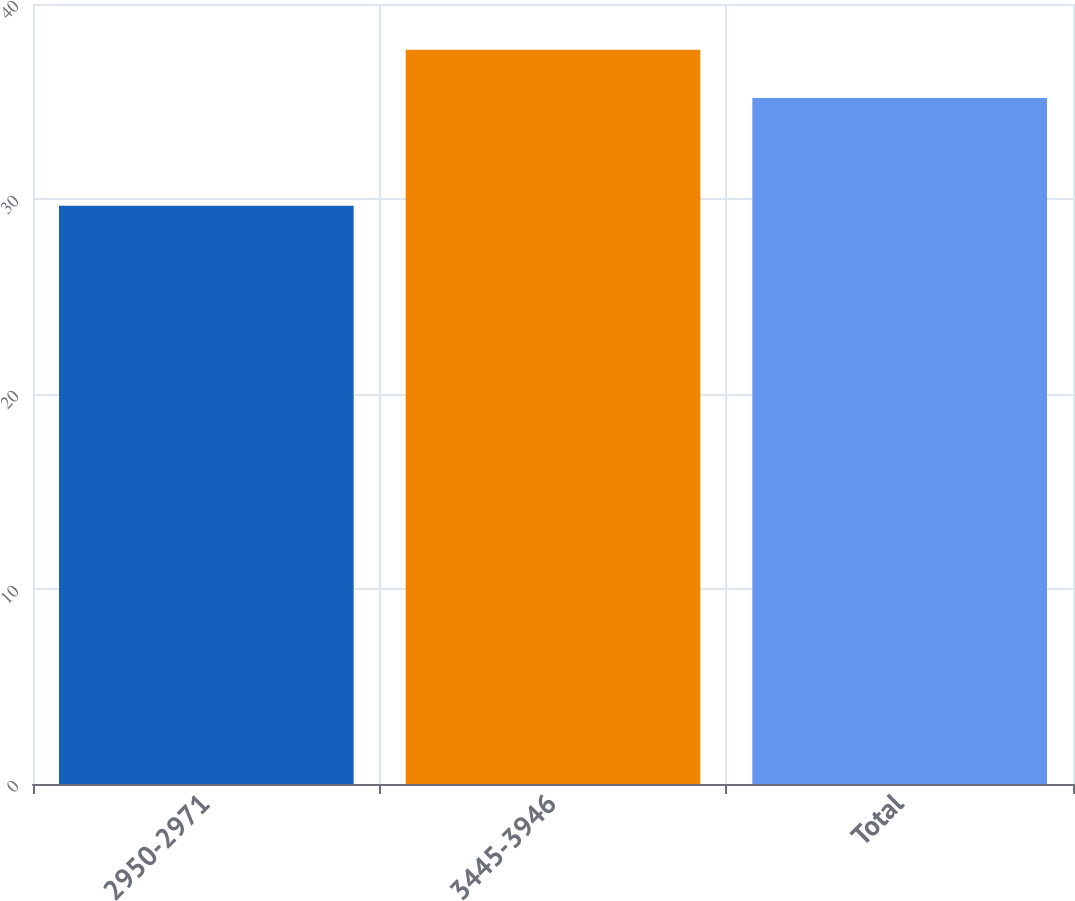<chart> <loc_0><loc_0><loc_500><loc_500><bar_chart><fcel>2950-2971<fcel>3445-3946<fcel>Total<nl><fcel>29.66<fcel>37.66<fcel>35.18<nl></chart> 